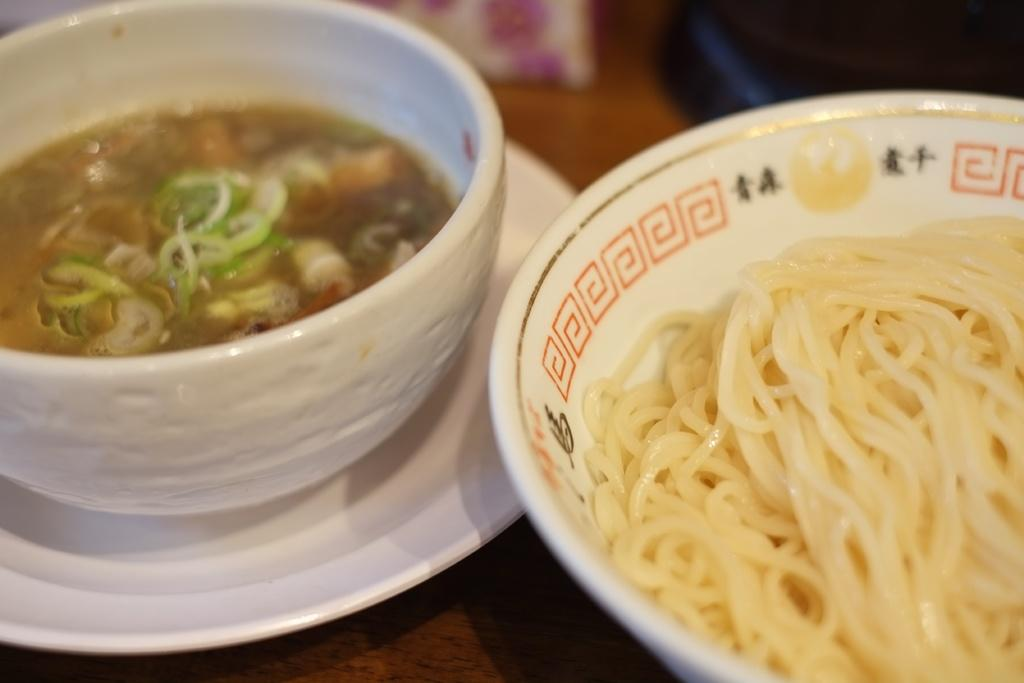How many bowls are visible in the image? There are two bowls in the image. What is in the first bowl? The first bowl contains noodles. What is in the second bowl? The second bowl contains some food. Where are the bowls placed? The bowls are on a plate. Where is the plate located? The plate is on a table. Is there a kitten performing on a stage in the image? No, there is no kitten or stage present in the image. 